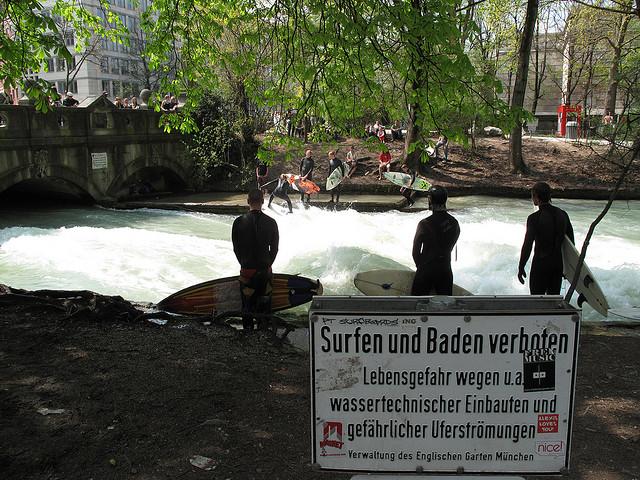What are they waiting for?
Keep it brief. Their turn. Is this the ocean?
Write a very short answer. No. Is the sign written in English?
Answer briefly. No. 